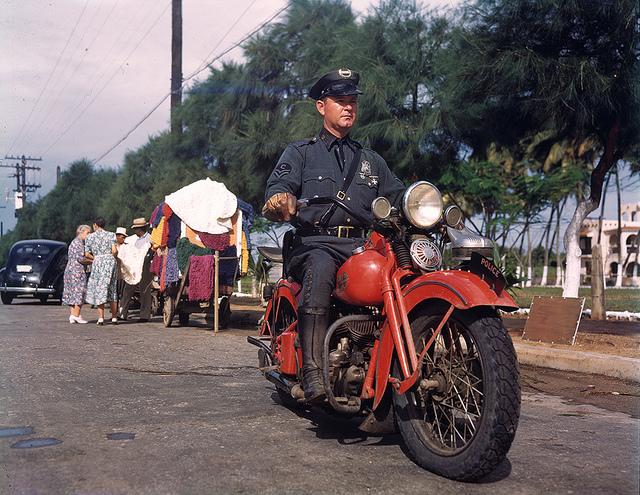What color is the motorcycle?
Concise answer only. Red. Is the man's shirt solid color?
Answer briefly. Yes. What is preventing the bike from falling over?
Answer briefly. Man. What accessory is the bog wearing?
Give a very brief answer. Hat. Was this motorcycle produced in the last 10 years?
Write a very short answer. No. What is the occupation of the rider?
Give a very brief answer. Policeman. Is he wearing a helmet?
Write a very short answer. No. 